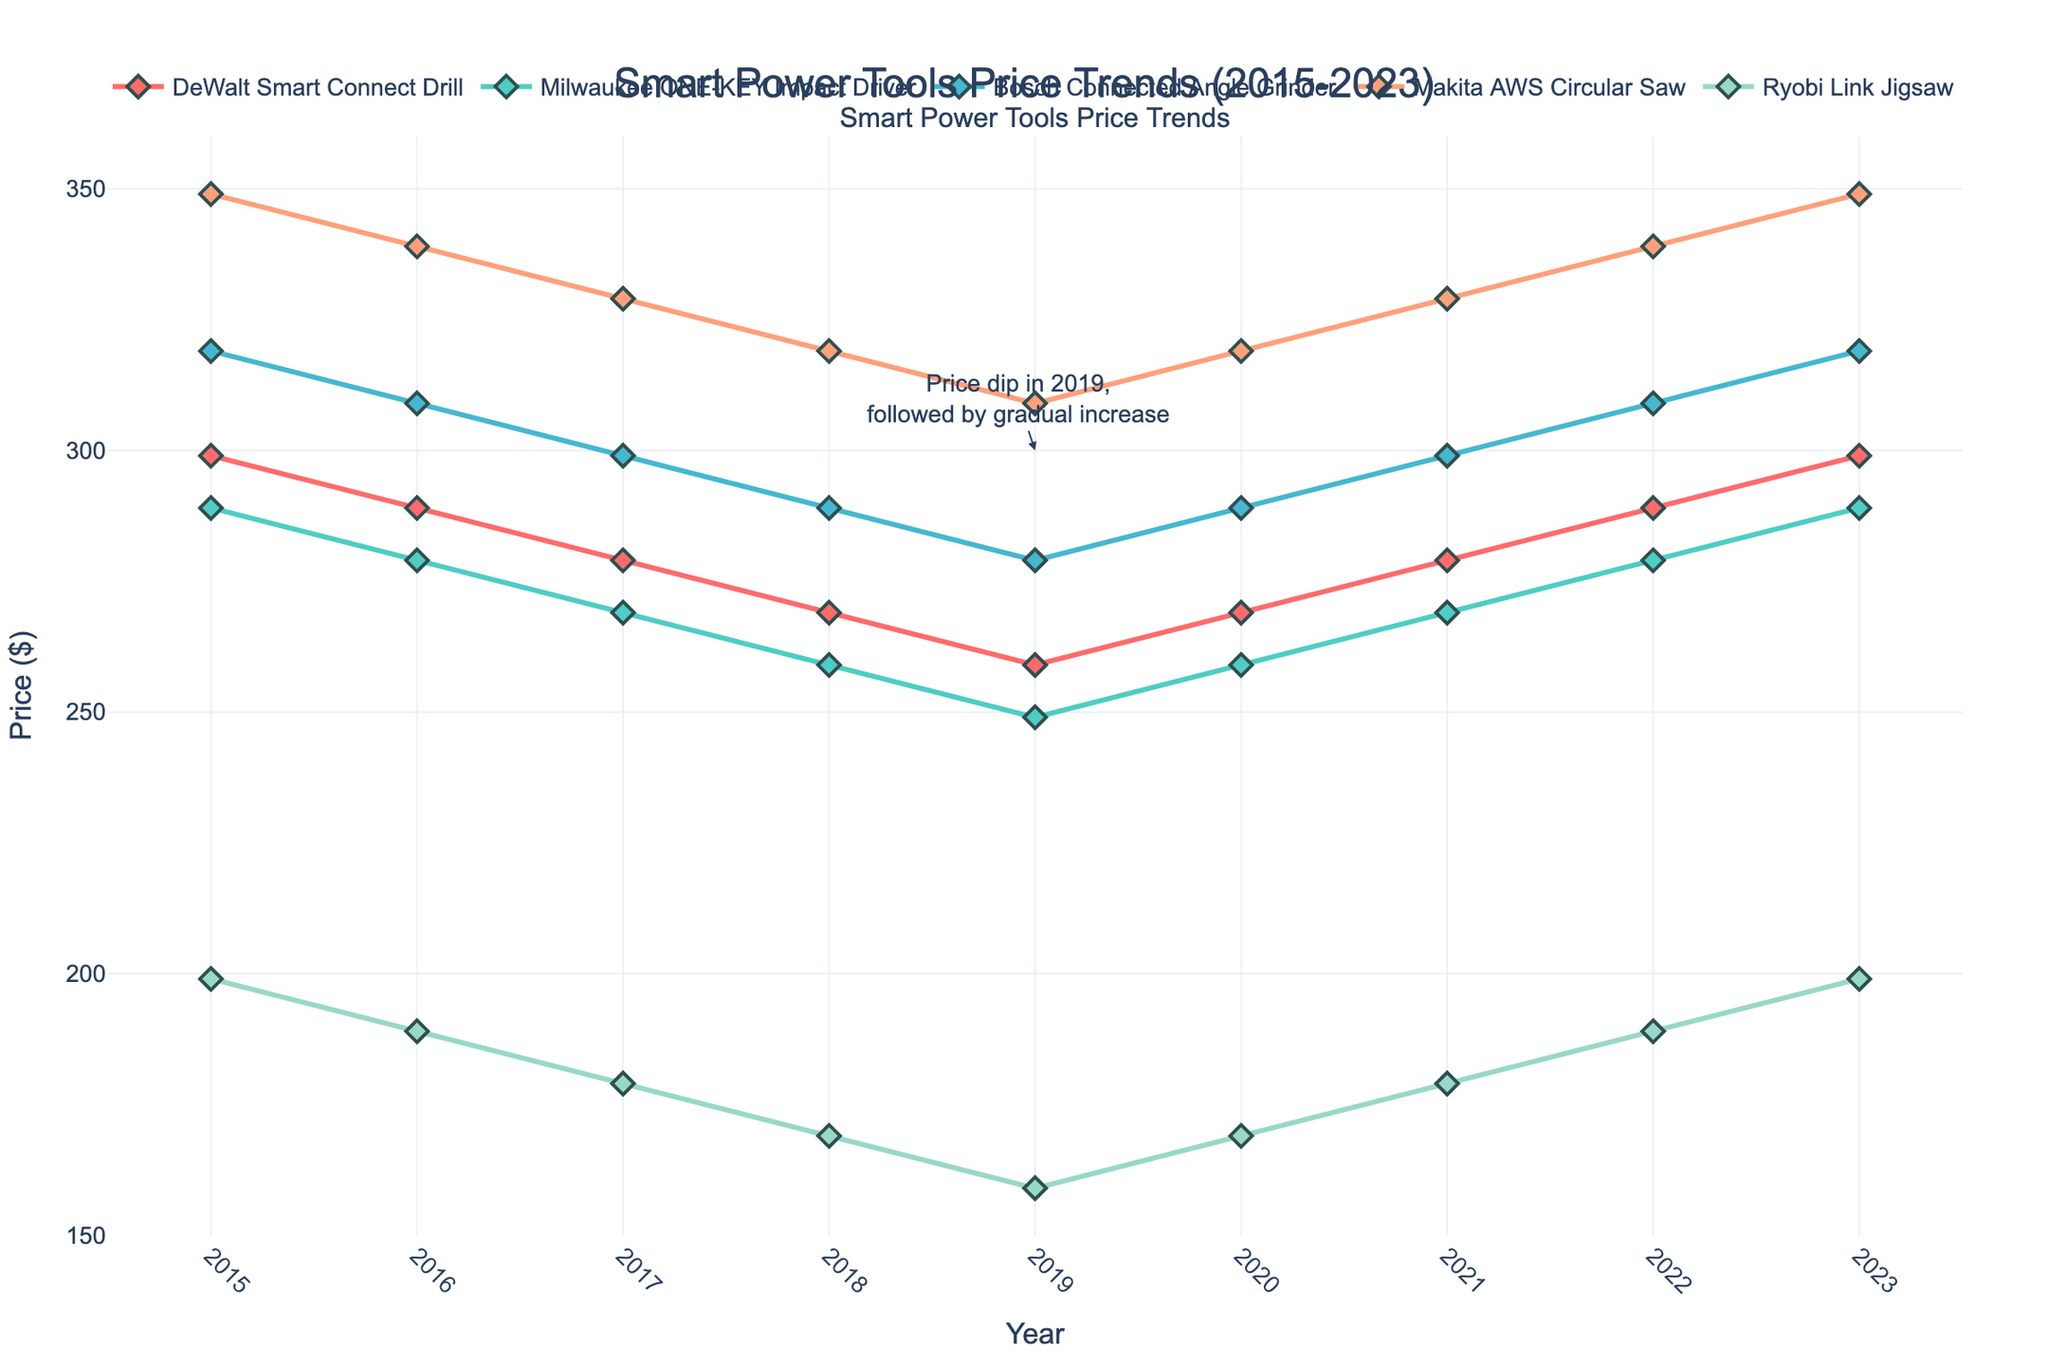What year saw the lowest average price for the Ryobi Link Jigsaw? By examining the figure, we can see that the Ryobi Link Jigsaw's price was the lowest in 2019, indicated by the dip to $159.
Answer: 2019 Which tool experienced a price dip in 2019, followed by a gradual increase? The annotation on the figure points out that there was a price dip in 2019 followed by a gradual increase. By looking at the trend for each tool, we see this pattern in the price trend for the DeWalt Smart Connect Drill.
Answer: DeWalt Smart Connect Drill Between 2015 and 2023, which year's price for the Makita AWS Circular Saw was the lowest, and what was that price? By looking at the trend line for the Makita AWS Circular Saw, the lowest price occurs in 2019, with a price of $309.
Answer: 2019, $309 What is the difference in price between the Bosch Connected Angle Grinder and the Milwaukee ONE-KEY Impact Driver in 2018? In 2018, the price of the Bosch Connected Angle Grinder was $289, and the price for the Milwaukee ONE-KEY Impact Driver was $259. The difference is calculated as $289 - $259 = $30.
Answer: $30 Which tool's price pattern repeats over the years, showing a cyclic but consistent trend from 2015 to 2023? By analyzing the trends, the Makita AWS Circular Saw shows a repeating price pattern with a dip followed by an increase, returning to the initial price by 2023.
Answer: Makita AWS Circular Saw In 2020, three tools have the same price. Identify them and state their price. Looking at the year 2020, the prices for DeWalt Smart Connect Drill, Bosch Connected Angle Grinder, and Makita AWS Circular Saw are all $289.
Answer: DeWalt Smart Connect Drill, Bosch Connected Angle Grinder, and Makita AWS Circular Saw, $289 Compare the price trends of DeWalt Smart Connect Drill and Ryobi Link Jigsaw. Which tool's price decreased the most between 2015 and 2019? Between 2015 and 2019, the DeWalt Smart Connect Drill dropped from $299 to $259, a decrease of $40. Ryobi Link Jigsaw dropped from $199 to $159, a decrease of $40. Both decreased by $40, so neither decreased more than the other.
Answer: Equal, $40 each Which tool has the most stable price trend and shows the least fluctuation over the years? By comparing the lines' stability, the Milwaukee ONE-KEY Impact Driver shows the least fluctuation, with consistent price declines and increases without abrupt changes.
Answer: Milwaukee ONE-KEY Impact Driver In which year did the Bosch Connected Angle Grinder have the same price as the Makita AWS Circular Saw, and what was that price? In 2020, the price of both the Bosch Connected Angle Grinder and the Makita AWS Circular Saw was $289.
Answer: 2020, $289 